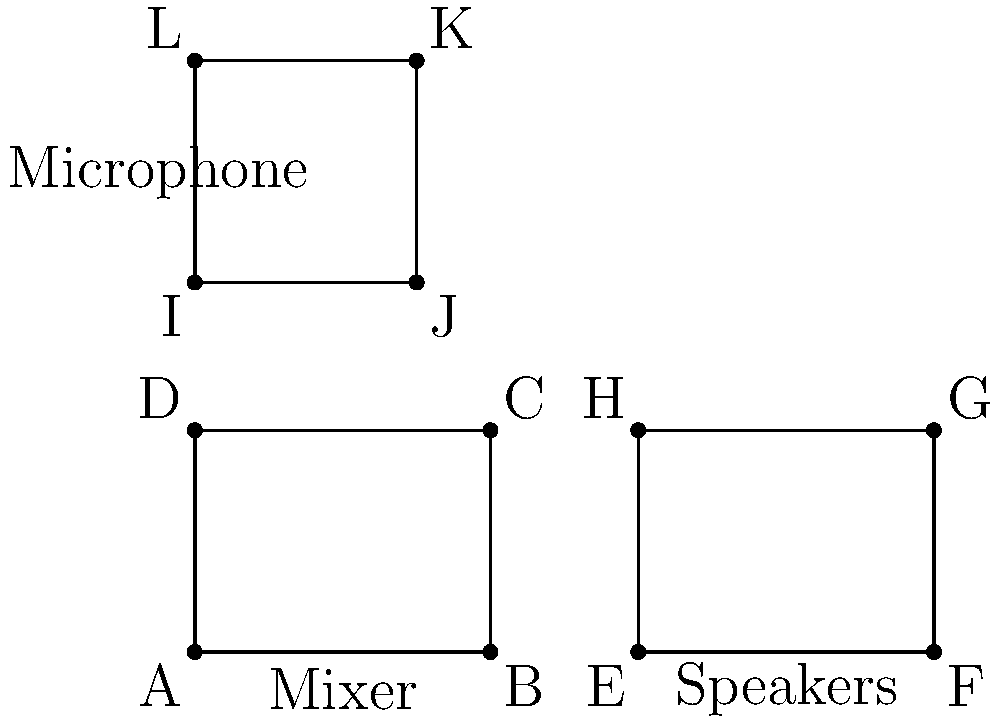In your studio setup diagram, which pairs of equipment shapes are congruent? Identify all congruent pairs using the labeled points. To determine congruence, we need to compare the shapes of the equipment in the diagram:

1. The mixer (ABCD) is a rectangle with width 4 units and height 3 units.
2. The speakers (EFGH) are also a rectangle with width 4 units and height 3 units.
3. The microphone (IJKL) is a rectangle with width 3 units and height 3 units.

Step 1: Compare ABCD and EFGH
- Both have the same width (4 units) and height (3 units).
- They have four right angles.
- Their corresponding sides are equal.
Therefore, ABCD is congruent to EFGH.

Step 2: Compare ABCD and IJKL
- They have different dimensions (4x3 vs 3x3).
Therefore, ABCD is not congruent to IJKL.

Step 3: Compare EFGH and IJKL
- They have different dimensions (4x3 vs 3x3).
Therefore, EFGH is not congruent to IJKL.

Conclusion: The only congruent pair of shapes in this studio equipment setup is the mixer (ABCD) and the speakers (EFGH).
Answer: ABCD and EFGH 